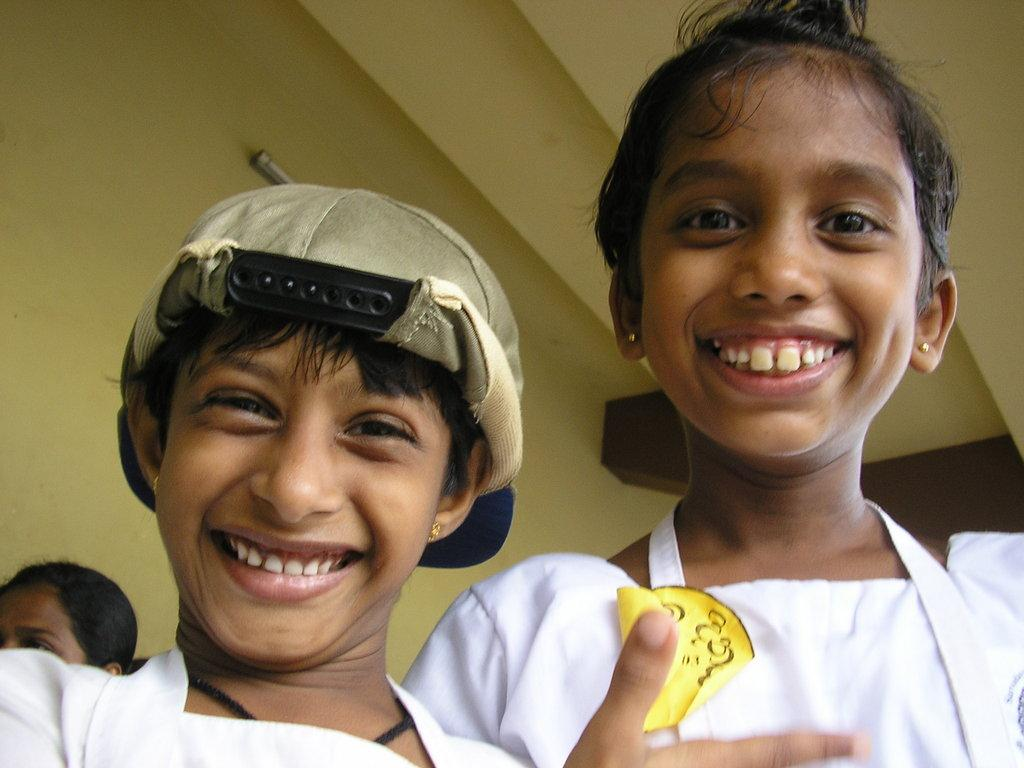Who is present in the image? There are girls in the image. Where are the girls located in the image? The girls are at the bottom of the image. What expression do the girls have? The girls are smiling. What color are the dresses the girls are wearing? The girls are wearing white color dresses. What can be seen in the background of the image? There is a wall in the background of the image. What type of alley can be seen behind the girls in the image? There is no alley visible in the image; it only shows a wall in the background. What time of day is it in the image, based on the hour? The provided facts do not mention the time of day or any specific hour, so it cannot be determined from the image. 